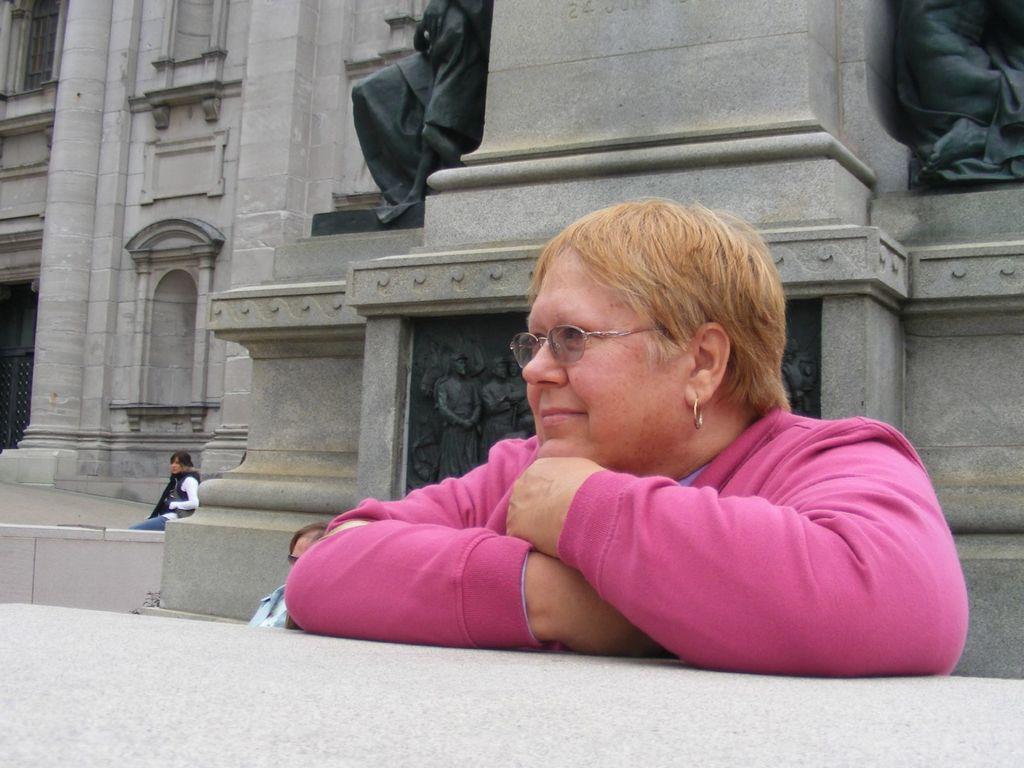Please provide a concise description of this image. In this image I can see some people. I can see some statue on the wall. 